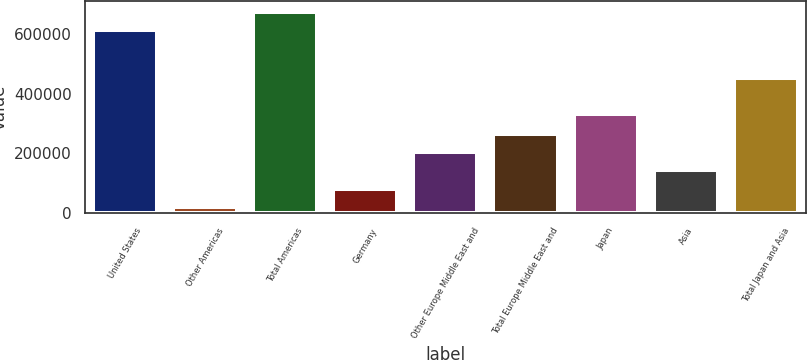<chart> <loc_0><loc_0><loc_500><loc_500><bar_chart><fcel>United States<fcel>Other Americas<fcel>Total Americas<fcel>Germany<fcel>Other Europe Middle East and<fcel>Total Europe Middle East and<fcel>Japan<fcel>Asia<fcel>Total Japan and Asia<nl><fcel>613186<fcel>20335<fcel>674505<fcel>81653.6<fcel>204291<fcel>265609<fcel>333233<fcel>142972<fcel>450680<nl></chart> 